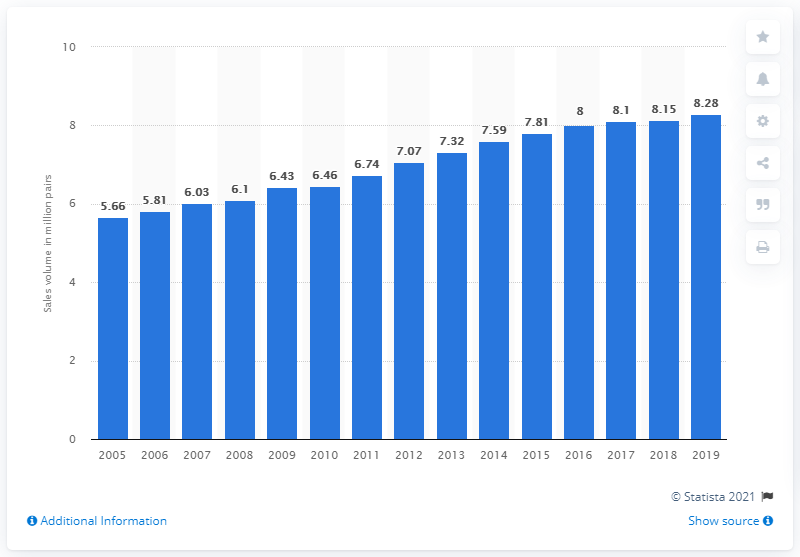Give some essential details in this illustration. Fielmann AG sold 8,280 pairs of glasses in Europe in 2019. 